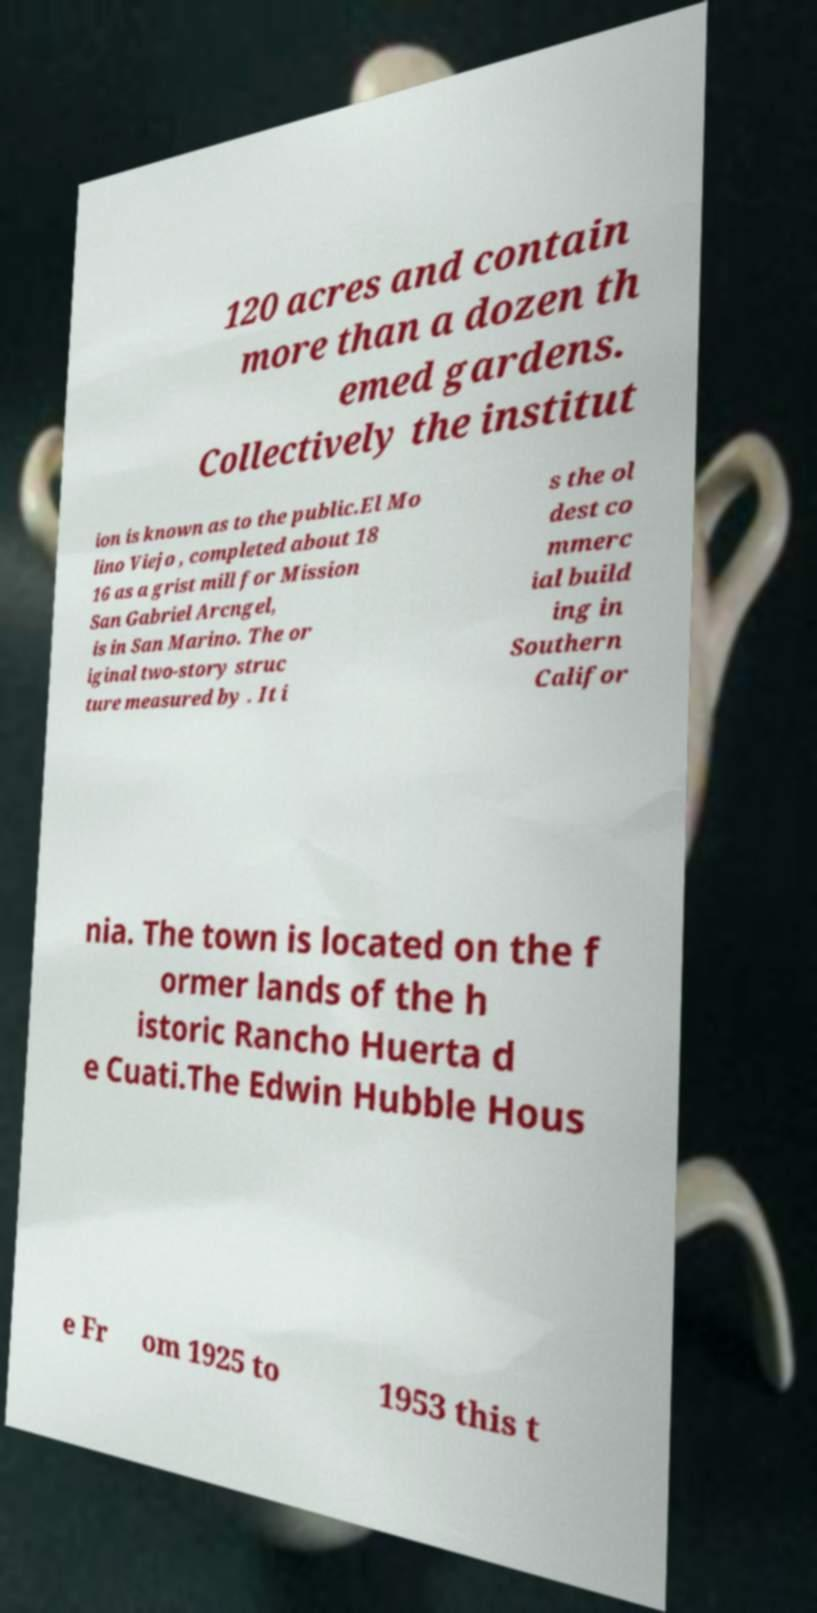Can you read and provide the text displayed in the image?This photo seems to have some interesting text. Can you extract and type it out for me? 120 acres and contain more than a dozen th emed gardens. Collectively the institut ion is known as to the public.El Mo lino Viejo , completed about 18 16 as a grist mill for Mission San Gabriel Arcngel, is in San Marino. The or iginal two-story struc ture measured by . It i s the ol dest co mmerc ial build ing in Southern Califor nia. The town is located on the f ormer lands of the h istoric Rancho Huerta d e Cuati.The Edwin Hubble Hous e Fr om 1925 to 1953 this t 